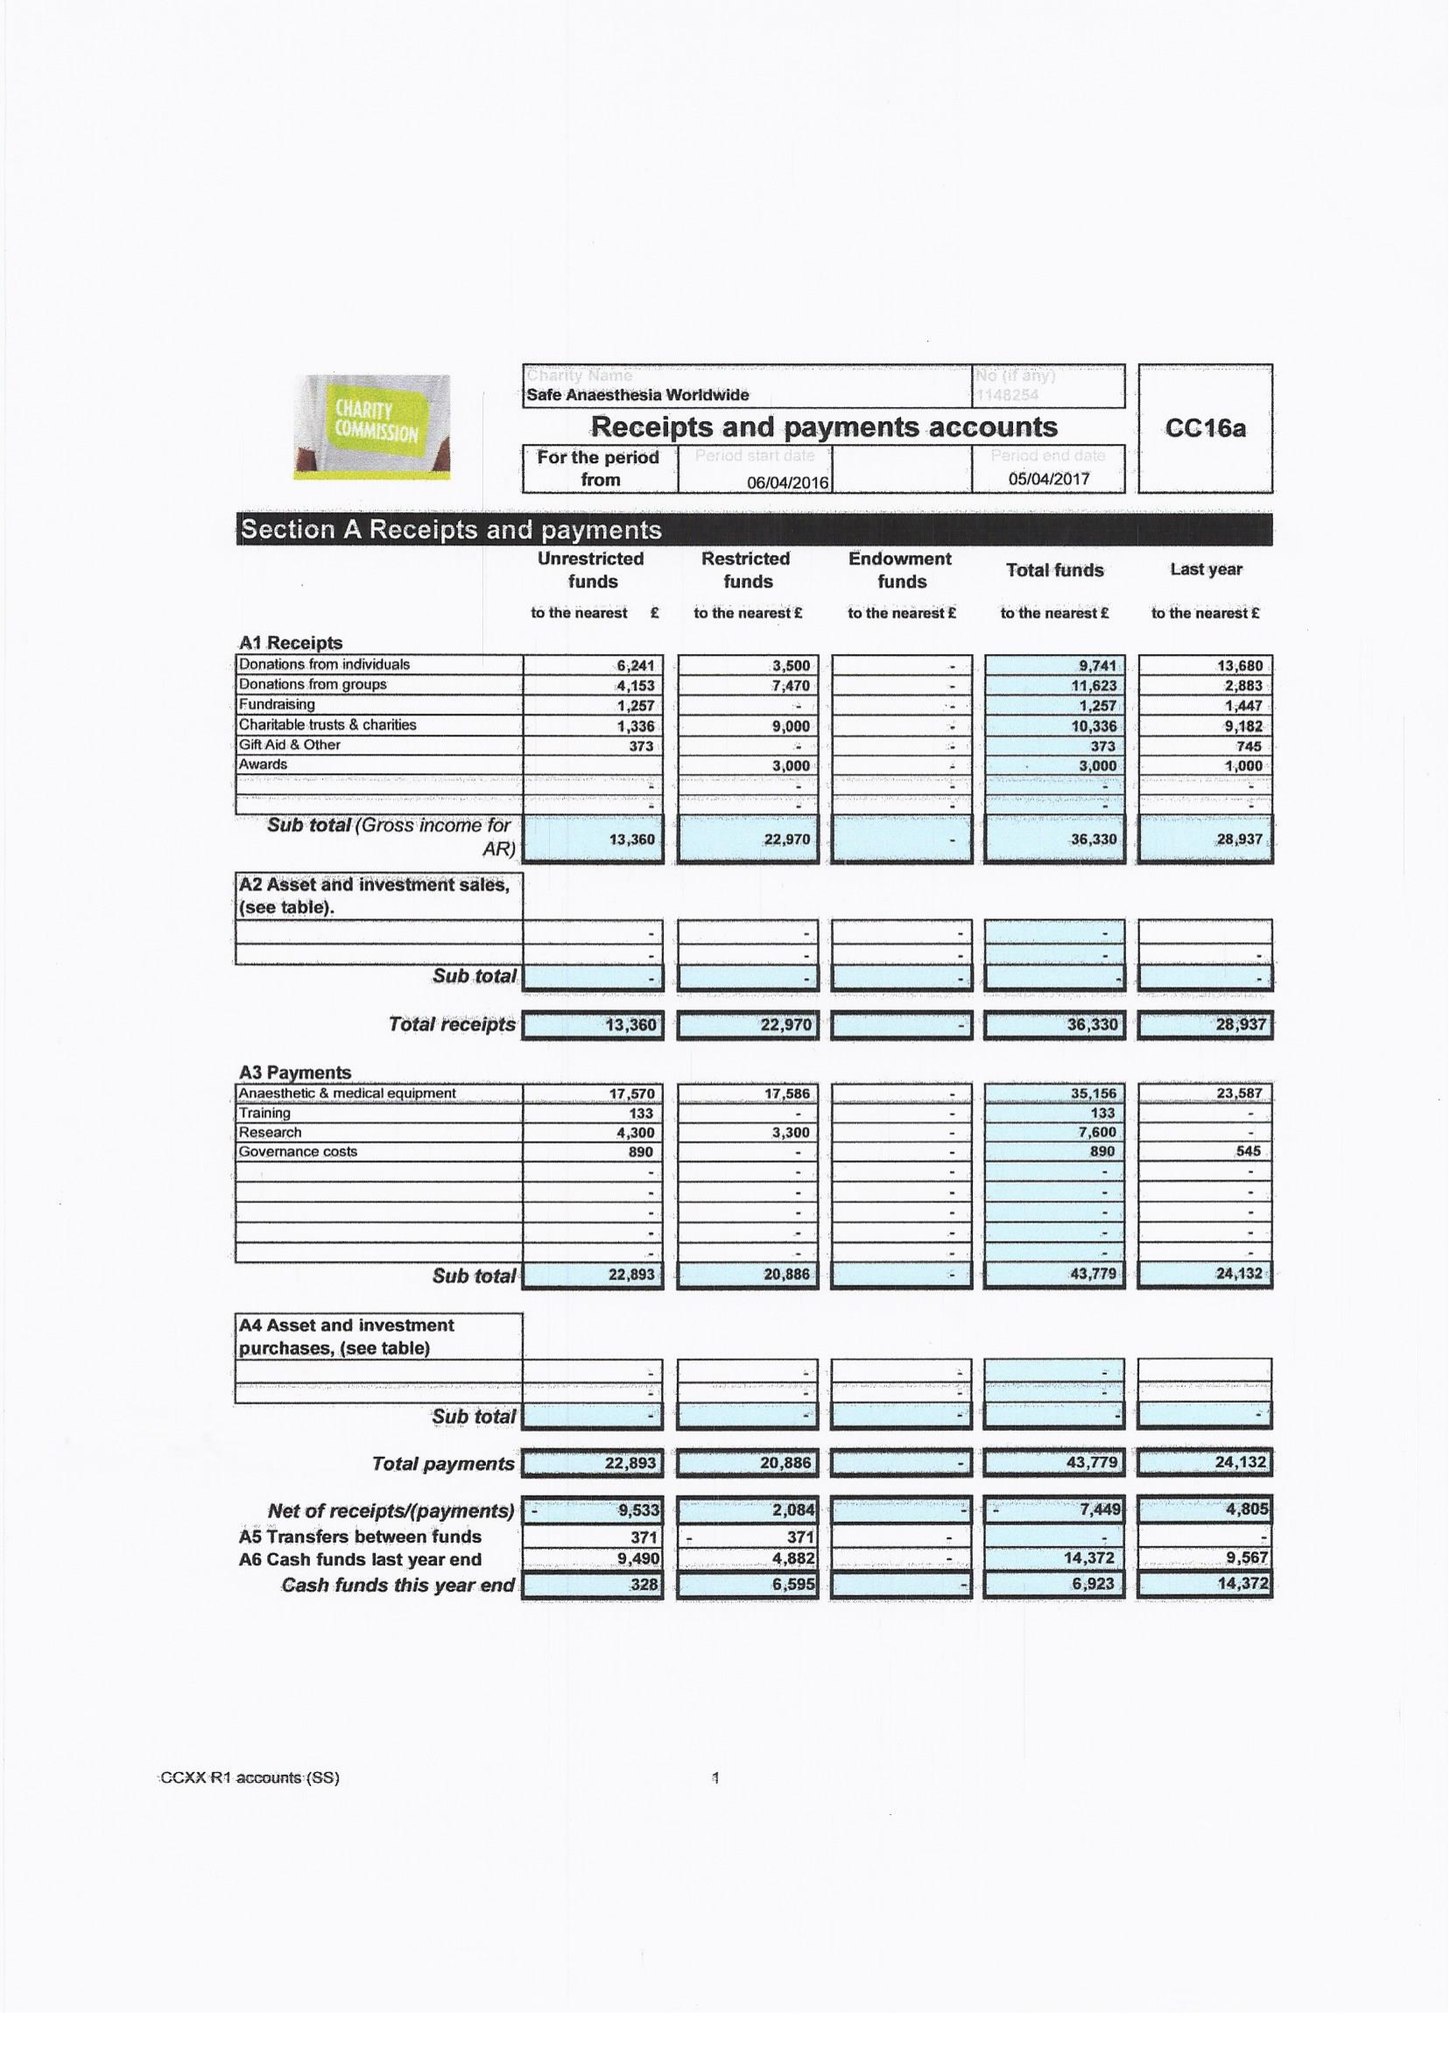What is the value for the report_date?
Answer the question using a single word or phrase. 2017-04-05 